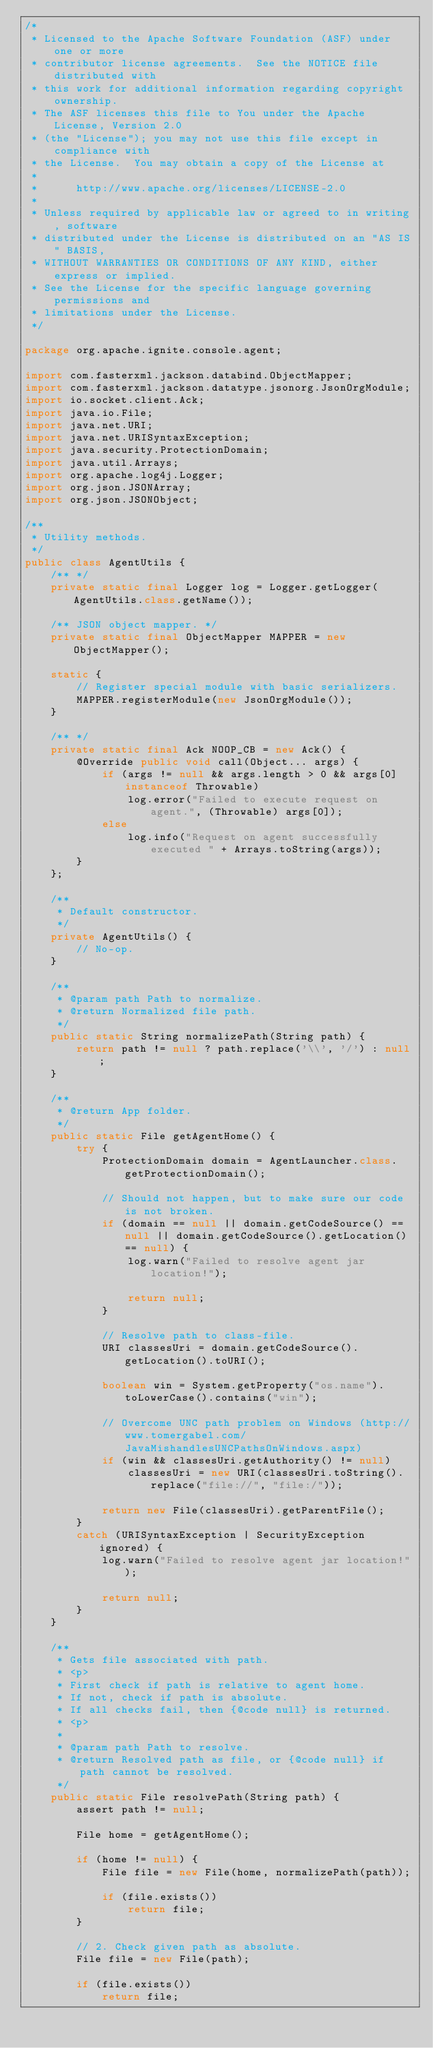<code> <loc_0><loc_0><loc_500><loc_500><_Java_>/*
 * Licensed to the Apache Software Foundation (ASF) under one or more
 * contributor license agreements.  See the NOTICE file distributed with
 * this work for additional information regarding copyright ownership.
 * The ASF licenses this file to You under the Apache License, Version 2.0
 * (the "License"); you may not use this file except in compliance with
 * the License.  You may obtain a copy of the License at
 *
 *      http://www.apache.org/licenses/LICENSE-2.0
 *
 * Unless required by applicable law or agreed to in writing, software
 * distributed under the License is distributed on an "AS IS" BASIS,
 * WITHOUT WARRANTIES OR CONDITIONS OF ANY KIND, either express or implied.
 * See the License for the specific language governing permissions and
 * limitations under the License.
 */

package org.apache.ignite.console.agent;

import com.fasterxml.jackson.databind.ObjectMapper;
import com.fasterxml.jackson.datatype.jsonorg.JsonOrgModule;
import io.socket.client.Ack;
import java.io.File;
import java.net.URI;
import java.net.URISyntaxException;
import java.security.ProtectionDomain;
import java.util.Arrays;
import org.apache.log4j.Logger;
import org.json.JSONArray;
import org.json.JSONObject;

/**
 * Utility methods.
 */
public class AgentUtils {
    /** */
    private static final Logger log = Logger.getLogger(AgentUtils.class.getName());

    /** JSON object mapper. */
    private static final ObjectMapper MAPPER = new ObjectMapper();

    static {
        // Register special module with basic serializers.
        MAPPER.registerModule(new JsonOrgModule());
    }

    /** */
    private static final Ack NOOP_CB = new Ack() {
        @Override public void call(Object... args) {
            if (args != null && args.length > 0 && args[0] instanceof Throwable)
                log.error("Failed to execute request on agent.", (Throwable) args[0]);
            else
                log.info("Request on agent successfully executed " + Arrays.toString(args));
        }
    };

    /**
     * Default constructor.
     */
    private AgentUtils() {
        // No-op.
    }

    /**
     * @param path Path to normalize.
     * @return Normalized file path.
     */
    public static String normalizePath(String path) {
        return path != null ? path.replace('\\', '/') : null;
    }

    /**
     * @return App folder.
     */
    public static File getAgentHome() {
        try {
            ProtectionDomain domain = AgentLauncher.class.getProtectionDomain();

            // Should not happen, but to make sure our code is not broken.
            if (domain == null || domain.getCodeSource() == null || domain.getCodeSource().getLocation() == null) {
                log.warn("Failed to resolve agent jar location!");

                return null;
            }

            // Resolve path to class-file.
            URI classesUri = domain.getCodeSource().getLocation().toURI();

            boolean win = System.getProperty("os.name").toLowerCase().contains("win");

            // Overcome UNC path problem on Windows (http://www.tomergabel.com/JavaMishandlesUNCPathsOnWindows.aspx)
            if (win && classesUri.getAuthority() != null)
                classesUri = new URI(classesUri.toString().replace("file://", "file:/"));

            return new File(classesUri).getParentFile();
        }
        catch (URISyntaxException | SecurityException ignored) {
            log.warn("Failed to resolve agent jar location!");

            return null;
        }
    }

    /**
     * Gets file associated with path.
     * <p>
     * First check if path is relative to agent home.
     * If not, check if path is absolute.
     * If all checks fail, then {@code null} is returned.
     * <p>
     *
     * @param path Path to resolve.
     * @return Resolved path as file, or {@code null} if path cannot be resolved.
     */
    public static File resolvePath(String path) {
        assert path != null;

        File home = getAgentHome();

        if (home != null) {
            File file = new File(home, normalizePath(path));

            if (file.exists())
                return file;
        }

        // 2. Check given path as absolute.
        File file = new File(path);

        if (file.exists())
            return file;
</code> 